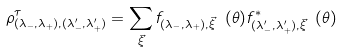Convert formula to latex. <formula><loc_0><loc_0><loc_500><loc_500>\rho ^ { \tau } _ { ( \lambda _ { - } , \lambda _ { + } ) , ( \lambda _ { - } ^ { \prime } , \lambda _ { + } ^ { \prime } ) } = \sum _ { \vec { \xi } } f _ { ( \lambda _ { - } , \lambda _ { + } ) , \vec { \xi } } \ ( \theta ) f ^ { * } _ { ( \lambda _ { - } ^ { \prime } , \lambda _ { + } ^ { \prime } ) , \vec { \xi } } \ ( \theta )</formula> 